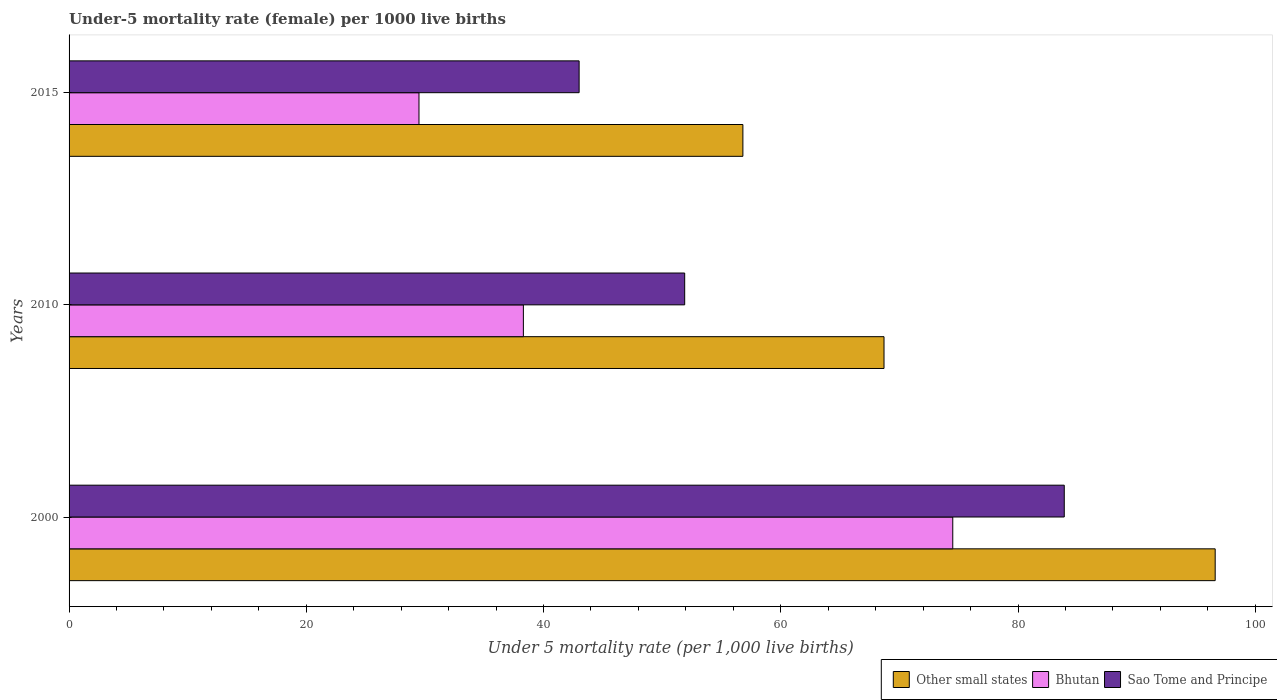How many groups of bars are there?
Give a very brief answer. 3. Are the number of bars per tick equal to the number of legend labels?
Ensure brevity in your answer.  Yes. What is the label of the 2nd group of bars from the top?
Make the answer very short. 2010. In how many cases, is the number of bars for a given year not equal to the number of legend labels?
Offer a terse response. 0. What is the under-five mortality rate in Other small states in 2010?
Your answer should be compact. 68.7. Across all years, what is the maximum under-five mortality rate in Sao Tome and Principe?
Your answer should be very brief. 83.9. In which year was the under-five mortality rate in Sao Tome and Principe maximum?
Provide a succinct answer. 2000. In which year was the under-five mortality rate in Bhutan minimum?
Keep it short and to the point. 2015. What is the total under-five mortality rate in Sao Tome and Principe in the graph?
Make the answer very short. 178.8. What is the difference between the under-five mortality rate in Bhutan in 2010 and that in 2015?
Provide a short and direct response. 8.8. What is the difference between the under-five mortality rate in Sao Tome and Principe in 2010 and the under-five mortality rate in Bhutan in 2000?
Ensure brevity in your answer.  -22.6. What is the average under-five mortality rate in Bhutan per year?
Keep it short and to the point. 47.43. In the year 2010, what is the difference between the under-five mortality rate in Other small states and under-five mortality rate in Bhutan?
Offer a terse response. 30.4. In how many years, is the under-five mortality rate in Sao Tome and Principe greater than 32 ?
Offer a very short reply. 3. What is the ratio of the under-five mortality rate in Other small states in 2000 to that in 2010?
Your answer should be very brief. 1.41. Is the difference between the under-five mortality rate in Other small states in 2010 and 2015 greater than the difference between the under-five mortality rate in Bhutan in 2010 and 2015?
Offer a terse response. Yes. What is the difference between the highest and the second highest under-five mortality rate in Bhutan?
Your answer should be very brief. 36.2. In how many years, is the under-five mortality rate in Sao Tome and Principe greater than the average under-five mortality rate in Sao Tome and Principe taken over all years?
Your answer should be compact. 1. What does the 2nd bar from the top in 2000 represents?
Offer a terse response. Bhutan. What does the 1st bar from the bottom in 2010 represents?
Give a very brief answer. Other small states. Is it the case that in every year, the sum of the under-five mortality rate in Sao Tome and Principe and under-five mortality rate in Bhutan is greater than the under-five mortality rate in Other small states?
Provide a short and direct response. Yes. How many bars are there?
Give a very brief answer. 9. How many years are there in the graph?
Your response must be concise. 3. Does the graph contain any zero values?
Give a very brief answer. No. Does the graph contain grids?
Ensure brevity in your answer.  No. Where does the legend appear in the graph?
Give a very brief answer. Bottom right. How many legend labels are there?
Keep it short and to the point. 3. What is the title of the graph?
Ensure brevity in your answer.  Under-5 mortality rate (female) per 1000 live births. What is the label or title of the X-axis?
Offer a very short reply. Under 5 mortality rate (per 1,0 live births). What is the label or title of the Y-axis?
Ensure brevity in your answer.  Years. What is the Under 5 mortality rate (per 1,000 live births) in Other small states in 2000?
Offer a very short reply. 96.62. What is the Under 5 mortality rate (per 1,000 live births) in Bhutan in 2000?
Ensure brevity in your answer.  74.5. What is the Under 5 mortality rate (per 1,000 live births) in Sao Tome and Principe in 2000?
Offer a very short reply. 83.9. What is the Under 5 mortality rate (per 1,000 live births) of Other small states in 2010?
Your response must be concise. 68.7. What is the Under 5 mortality rate (per 1,000 live births) in Bhutan in 2010?
Your response must be concise. 38.3. What is the Under 5 mortality rate (per 1,000 live births) in Sao Tome and Principe in 2010?
Provide a short and direct response. 51.9. What is the Under 5 mortality rate (per 1,000 live births) of Other small states in 2015?
Your answer should be very brief. 56.81. What is the Under 5 mortality rate (per 1,000 live births) in Bhutan in 2015?
Ensure brevity in your answer.  29.5. Across all years, what is the maximum Under 5 mortality rate (per 1,000 live births) in Other small states?
Keep it short and to the point. 96.62. Across all years, what is the maximum Under 5 mortality rate (per 1,000 live births) of Bhutan?
Offer a terse response. 74.5. Across all years, what is the maximum Under 5 mortality rate (per 1,000 live births) of Sao Tome and Principe?
Your answer should be compact. 83.9. Across all years, what is the minimum Under 5 mortality rate (per 1,000 live births) in Other small states?
Give a very brief answer. 56.81. Across all years, what is the minimum Under 5 mortality rate (per 1,000 live births) in Bhutan?
Your response must be concise. 29.5. What is the total Under 5 mortality rate (per 1,000 live births) in Other small states in the graph?
Provide a succinct answer. 222.13. What is the total Under 5 mortality rate (per 1,000 live births) in Bhutan in the graph?
Your response must be concise. 142.3. What is the total Under 5 mortality rate (per 1,000 live births) of Sao Tome and Principe in the graph?
Keep it short and to the point. 178.8. What is the difference between the Under 5 mortality rate (per 1,000 live births) of Other small states in 2000 and that in 2010?
Ensure brevity in your answer.  27.92. What is the difference between the Under 5 mortality rate (per 1,000 live births) in Bhutan in 2000 and that in 2010?
Give a very brief answer. 36.2. What is the difference between the Under 5 mortality rate (per 1,000 live births) of Other small states in 2000 and that in 2015?
Offer a very short reply. 39.82. What is the difference between the Under 5 mortality rate (per 1,000 live births) in Bhutan in 2000 and that in 2015?
Provide a short and direct response. 45. What is the difference between the Under 5 mortality rate (per 1,000 live births) of Sao Tome and Principe in 2000 and that in 2015?
Give a very brief answer. 40.9. What is the difference between the Under 5 mortality rate (per 1,000 live births) in Other small states in 2010 and that in 2015?
Ensure brevity in your answer.  11.9. What is the difference between the Under 5 mortality rate (per 1,000 live births) in Bhutan in 2010 and that in 2015?
Keep it short and to the point. 8.8. What is the difference between the Under 5 mortality rate (per 1,000 live births) of Other small states in 2000 and the Under 5 mortality rate (per 1,000 live births) of Bhutan in 2010?
Ensure brevity in your answer.  58.32. What is the difference between the Under 5 mortality rate (per 1,000 live births) of Other small states in 2000 and the Under 5 mortality rate (per 1,000 live births) of Sao Tome and Principe in 2010?
Provide a short and direct response. 44.72. What is the difference between the Under 5 mortality rate (per 1,000 live births) of Bhutan in 2000 and the Under 5 mortality rate (per 1,000 live births) of Sao Tome and Principe in 2010?
Your answer should be compact. 22.6. What is the difference between the Under 5 mortality rate (per 1,000 live births) of Other small states in 2000 and the Under 5 mortality rate (per 1,000 live births) of Bhutan in 2015?
Offer a terse response. 67.12. What is the difference between the Under 5 mortality rate (per 1,000 live births) of Other small states in 2000 and the Under 5 mortality rate (per 1,000 live births) of Sao Tome and Principe in 2015?
Give a very brief answer. 53.62. What is the difference between the Under 5 mortality rate (per 1,000 live births) in Bhutan in 2000 and the Under 5 mortality rate (per 1,000 live births) in Sao Tome and Principe in 2015?
Provide a succinct answer. 31.5. What is the difference between the Under 5 mortality rate (per 1,000 live births) of Other small states in 2010 and the Under 5 mortality rate (per 1,000 live births) of Bhutan in 2015?
Your response must be concise. 39.2. What is the difference between the Under 5 mortality rate (per 1,000 live births) of Other small states in 2010 and the Under 5 mortality rate (per 1,000 live births) of Sao Tome and Principe in 2015?
Provide a short and direct response. 25.7. What is the average Under 5 mortality rate (per 1,000 live births) of Other small states per year?
Your answer should be very brief. 74.04. What is the average Under 5 mortality rate (per 1,000 live births) of Bhutan per year?
Your response must be concise. 47.43. What is the average Under 5 mortality rate (per 1,000 live births) in Sao Tome and Principe per year?
Offer a terse response. 59.6. In the year 2000, what is the difference between the Under 5 mortality rate (per 1,000 live births) in Other small states and Under 5 mortality rate (per 1,000 live births) in Bhutan?
Offer a very short reply. 22.12. In the year 2000, what is the difference between the Under 5 mortality rate (per 1,000 live births) of Other small states and Under 5 mortality rate (per 1,000 live births) of Sao Tome and Principe?
Provide a short and direct response. 12.72. In the year 2000, what is the difference between the Under 5 mortality rate (per 1,000 live births) in Bhutan and Under 5 mortality rate (per 1,000 live births) in Sao Tome and Principe?
Offer a terse response. -9.4. In the year 2010, what is the difference between the Under 5 mortality rate (per 1,000 live births) in Other small states and Under 5 mortality rate (per 1,000 live births) in Bhutan?
Ensure brevity in your answer.  30.4. In the year 2010, what is the difference between the Under 5 mortality rate (per 1,000 live births) in Other small states and Under 5 mortality rate (per 1,000 live births) in Sao Tome and Principe?
Provide a succinct answer. 16.8. In the year 2010, what is the difference between the Under 5 mortality rate (per 1,000 live births) of Bhutan and Under 5 mortality rate (per 1,000 live births) of Sao Tome and Principe?
Offer a very short reply. -13.6. In the year 2015, what is the difference between the Under 5 mortality rate (per 1,000 live births) of Other small states and Under 5 mortality rate (per 1,000 live births) of Bhutan?
Give a very brief answer. 27.31. In the year 2015, what is the difference between the Under 5 mortality rate (per 1,000 live births) in Other small states and Under 5 mortality rate (per 1,000 live births) in Sao Tome and Principe?
Your response must be concise. 13.81. In the year 2015, what is the difference between the Under 5 mortality rate (per 1,000 live births) of Bhutan and Under 5 mortality rate (per 1,000 live births) of Sao Tome and Principe?
Give a very brief answer. -13.5. What is the ratio of the Under 5 mortality rate (per 1,000 live births) of Other small states in 2000 to that in 2010?
Offer a terse response. 1.41. What is the ratio of the Under 5 mortality rate (per 1,000 live births) in Bhutan in 2000 to that in 2010?
Your answer should be very brief. 1.95. What is the ratio of the Under 5 mortality rate (per 1,000 live births) of Sao Tome and Principe in 2000 to that in 2010?
Make the answer very short. 1.62. What is the ratio of the Under 5 mortality rate (per 1,000 live births) in Other small states in 2000 to that in 2015?
Make the answer very short. 1.7. What is the ratio of the Under 5 mortality rate (per 1,000 live births) in Bhutan in 2000 to that in 2015?
Offer a terse response. 2.53. What is the ratio of the Under 5 mortality rate (per 1,000 live births) in Sao Tome and Principe in 2000 to that in 2015?
Offer a terse response. 1.95. What is the ratio of the Under 5 mortality rate (per 1,000 live births) of Other small states in 2010 to that in 2015?
Keep it short and to the point. 1.21. What is the ratio of the Under 5 mortality rate (per 1,000 live births) of Bhutan in 2010 to that in 2015?
Provide a short and direct response. 1.3. What is the ratio of the Under 5 mortality rate (per 1,000 live births) in Sao Tome and Principe in 2010 to that in 2015?
Give a very brief answer. 1.21. What is the difference between the highest and the second highest Under 5 mortality rate (per 1,000 live births) in Other small states?
Your response must be concise. 27.92. What is the difference between the highest and the second highest Under 5 mortality rate (per 1,000 live births) of Bhutan?
Give a very brief answer. 36.2. What is the difference between the highest and the second highest Under 5 mortality rate (per 1,000 live births) in Sao Tome and Principe?
Make the answer very short. 32. What is the difference between the highest and the lowest Under 5 mortality rate (per 1,000 live births) of Other small states?
Offer a very short reply. 39.82. What is the difference between the highest and the lowest Under 5 mortality rate (per 1,000 live births) in Sao Tome and Principe?
Provide a succinct answer. 40.9. 